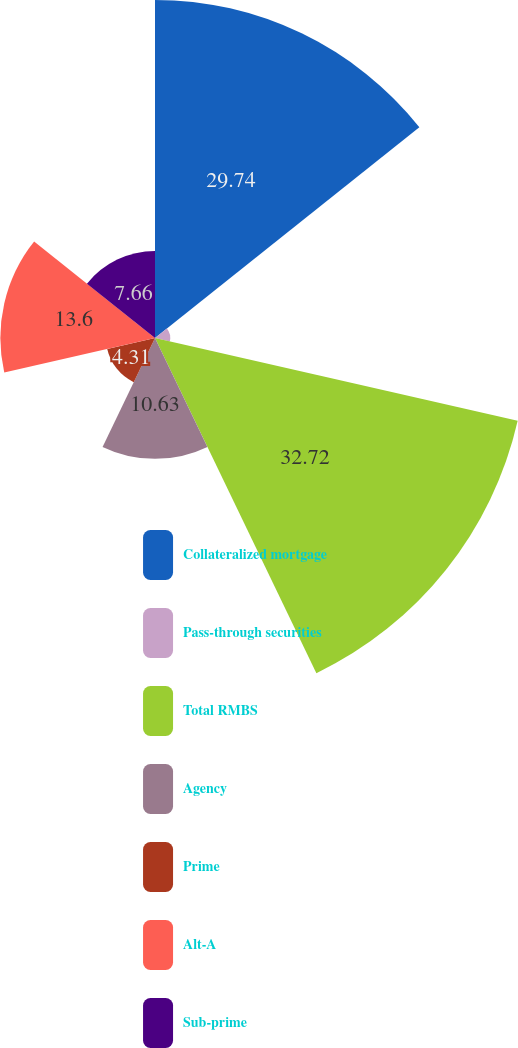<chart> <loc_0><loc_0><loc_500><loc_500><pie_chart><fcel>Collateralized mortgage<fcel>Pass-through securities<fcel>Total RMBS<fcel>Agency<fcel>Prime<fcel>Alt-A<fcel>Sub-prime<nl><fcel>29.74%<fcel>1.34%<fcel>32.72%<fcel>10.63%<fcel>4.31%<fcel>13.6%<fcel>7.66%<nl></chart> 